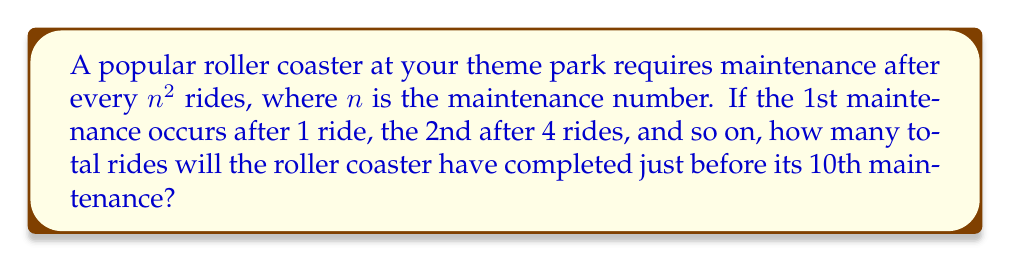Can you solve this math problem? Let's approach this step-by-step:

1) The sequence of maintenance intervals follows the pattern of perfect squares: $1^2, 2^2, 3^2, 4^2, ...$

2) We need to sum up the first 9 perfect squares, as we want the total rides before the 10th maintenance.

3) The sum of the first $k$ perfect squares is given by the formula:

   $$\sum_{i=1}^k i^2 = \frac{k(k+1)(2k+1)}{6}$$

4) In our case, $k = 9$, so we plug this into the formula:

   $$\sum_{i=1}^9 i^2 = \frac{9(9+1)(2\cdot9+1)}{6}$$

5) Let's calculate:
   $$\frac{9 \cdot 10 \cdot 19}{6} = \frac{1710}{6} = 285$$

6) Therefore, just before the 10th maintenance, the roller coaster will have completed 285 rides.

This calculation helps in planning maintenance schedules and estimating the lifespan of ride components, crucial for both safety and cost management in theme park operations.
Answer: 285 rides 